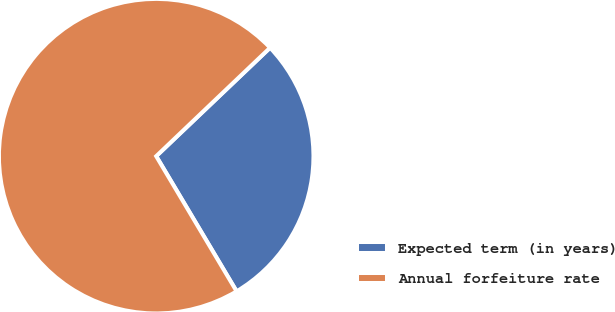Convert chart to OTSL. <chart><loc_0><loc_0><loc_500><loc_500><pie_chart><fcel>Expected term (in years)<fcel>Annual forfeiture rate<nl><fcel>28.57%<fcel>71.43%<nl></chart> 